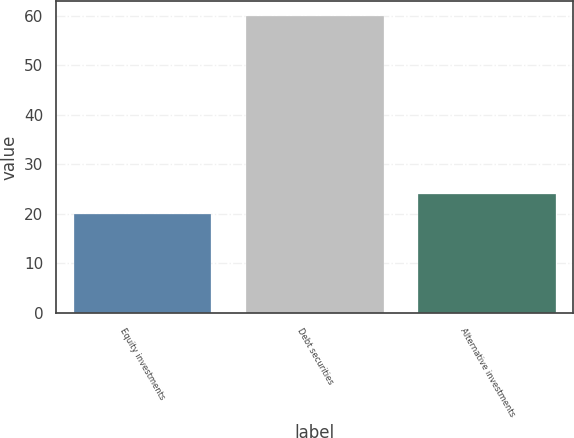Convert chart to OTSL. <chart><loc_0><loc_0><loc_500><loc_500><bar_chart><fcel>Equity investments<fcel>Debt securities<fcel>Alternative investments<nl><fcel>20<fcel>60<fcel>24<nl></chart> 